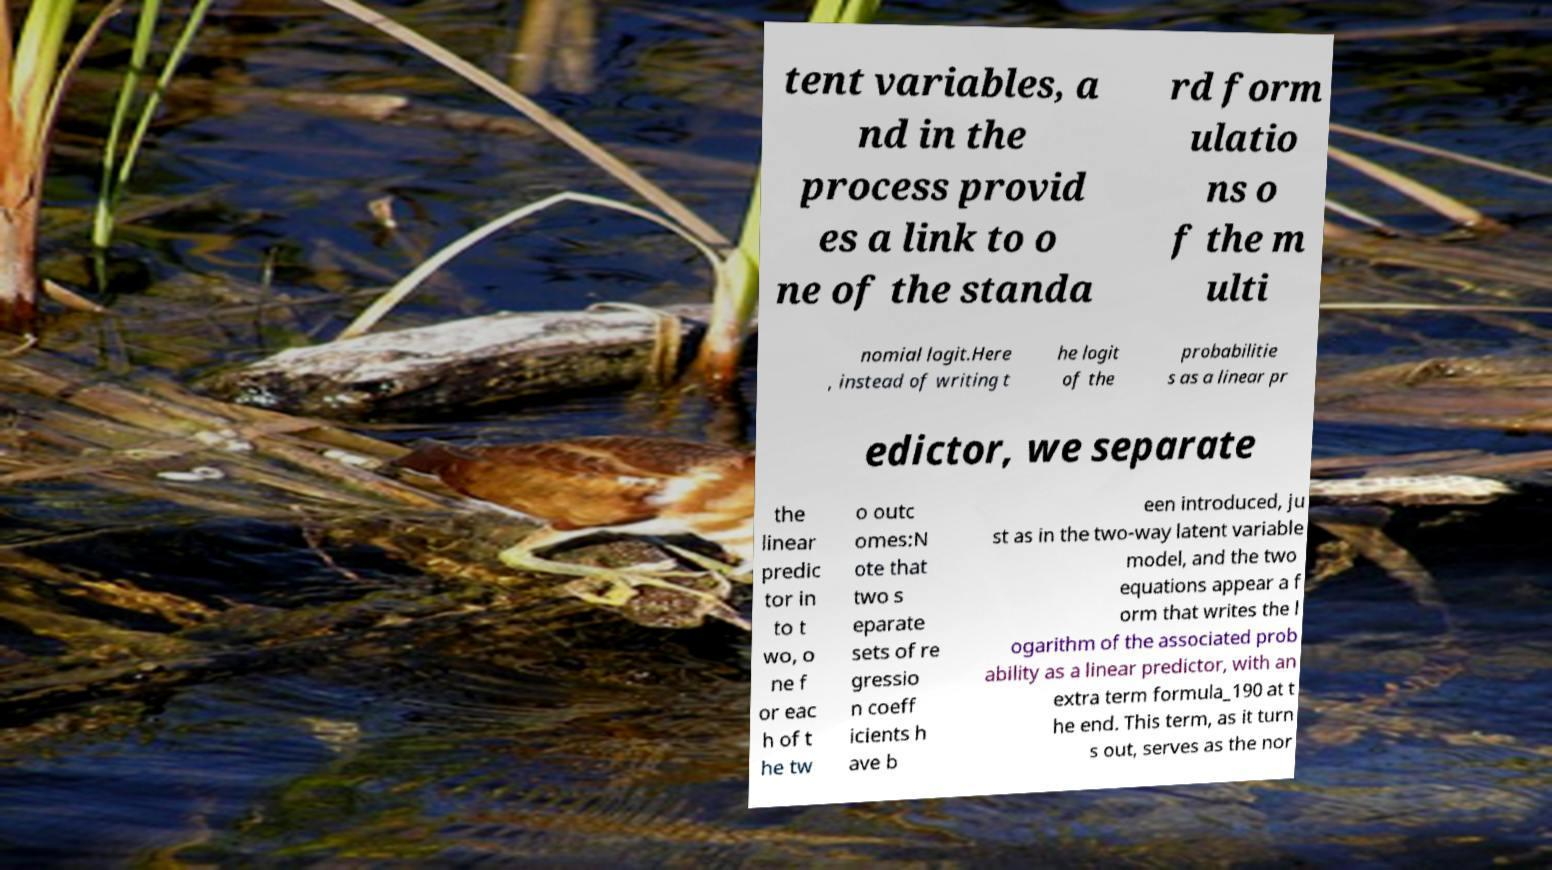For documentation purposes, I need the text within this image transcribed. Could you provide that? tent variables, a nd in the process provid es a link to o ne of the standa rd form ulatio ns o f the m ulti nomial logit.Here , instead of writing t he logit of the probabilitie s as a linear pr edictor, we separate the linear predic tor in to t wo, o ne f or eac h of t he tw o outc omes:N ote that two s eparate sets of re gressio n coeff icients h ave b een introduced, ju st as in the two-way latent variable model, and the two equations appear a f orm that writes the l ogarithm of the associated prob ability as a linear predictor, with an extra term formula_190 at t he end. This term, as it turn s out, serves as the nor 